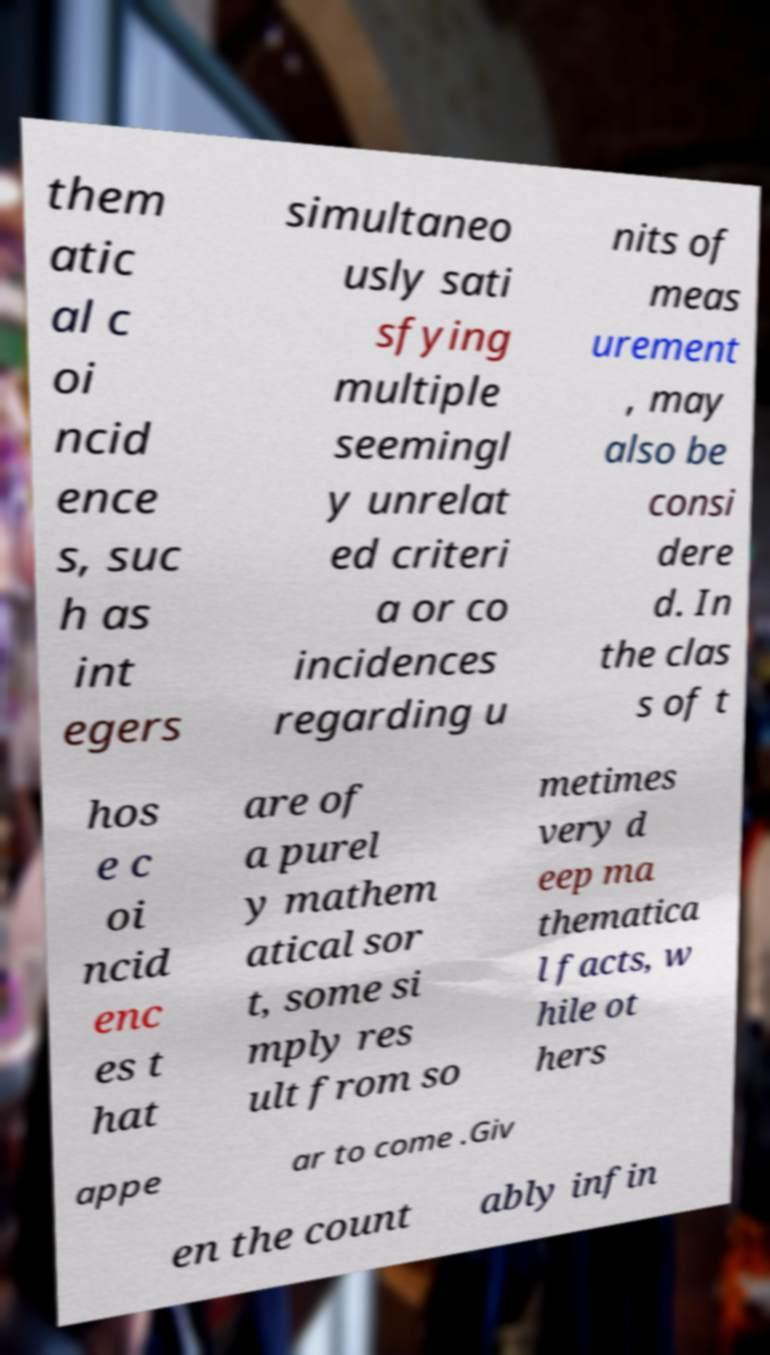I need the written content from this picture converted into text. Can you do that? them atic al c oi ncid ence s, suc h as int egers simultaneo usly sati sfying multiple seemingl y unrelat ed criteri a or co incidences regarding u nits of meas urement , may also be consi dere d. In the clas s of t hos e c oi ncid enc es t hat are of a purel y mathem atical sor t, some si mply res ult from so metimes very d eep ma thematica l facts, w hile ot hers appe ar to come .Giv en the count ably infin 